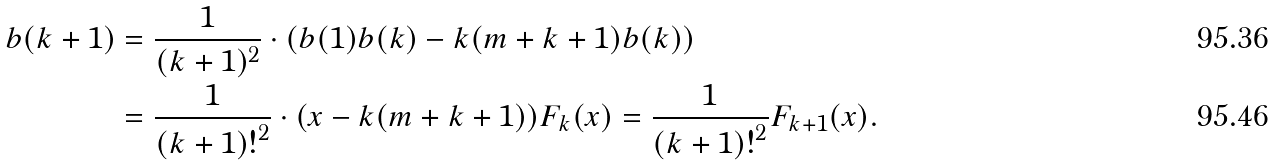Convert formula to latex. <formula><loc_0><loc_0><loc_500><loc_500>b ( { k + 1 } ) & = \frac { 1 } { ( k + 1 ) ^ { 2 } } \cdot ( b ( 1 ) b ( k ) - k ( m + k + 1 ) b ( k ) ) \\ & = \frac { 1 } { { ( k + 1 ) ! } ^ { 2 } } \cdot ( x - k ( m + k + 1 ) ) F _ { k } ( x ) = \frac { 1 } { { ( k + 1 ) ! } ^ { 2 } } F _ { k + 1 } ( x ) .</formula> 